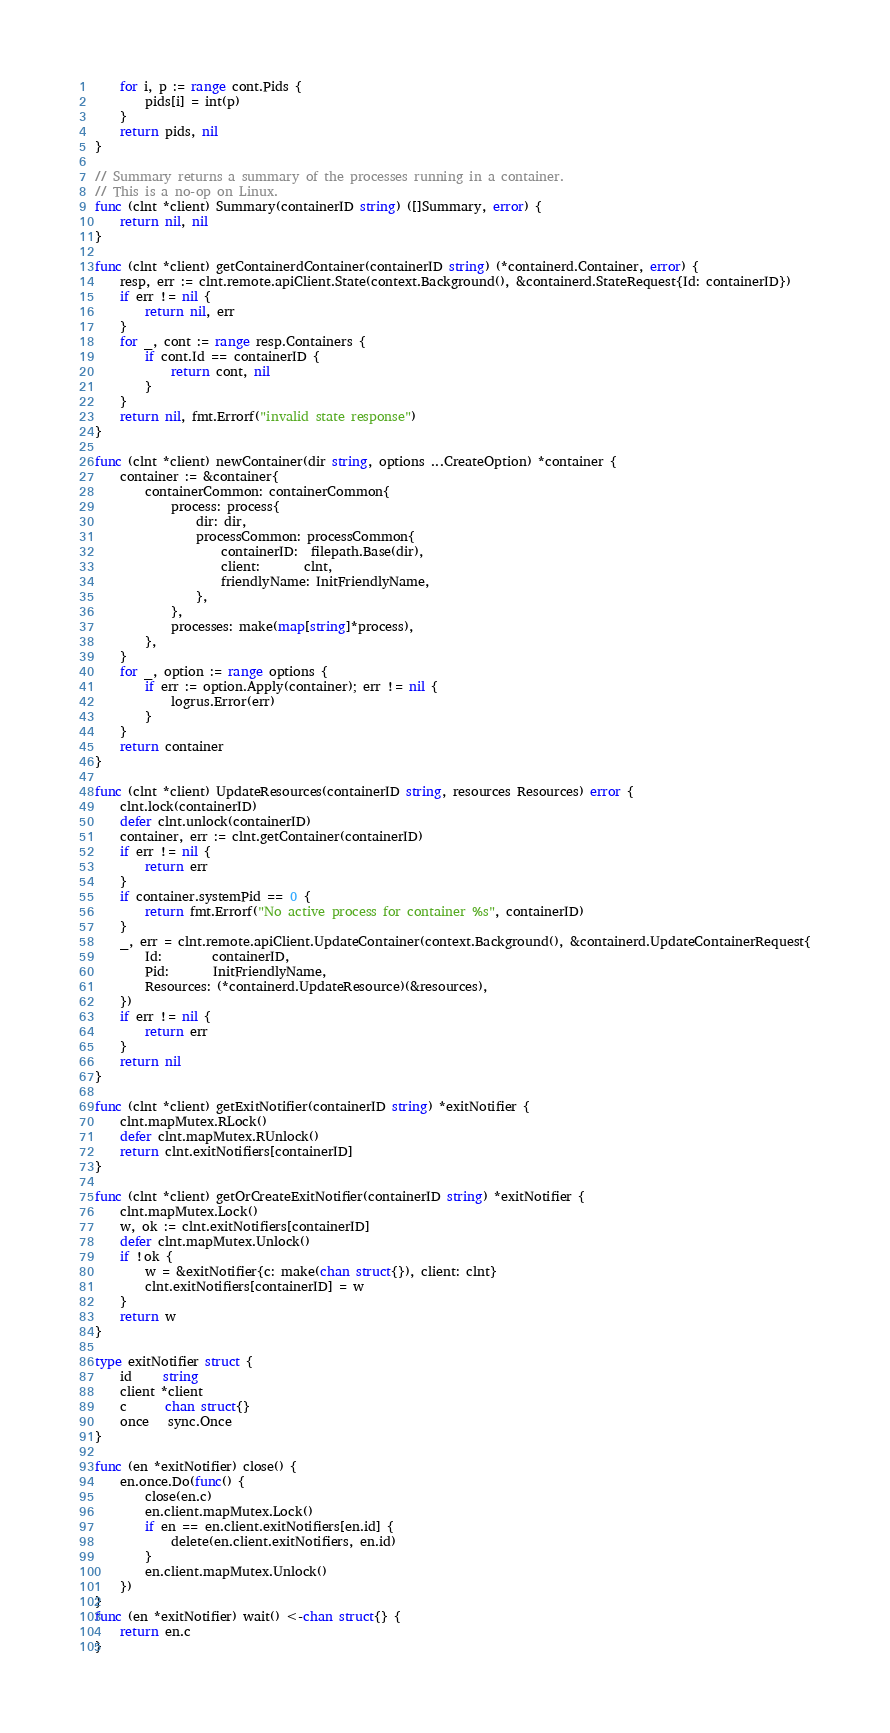<code> <loc_0><loc_0><loc_500><loc_500><_Go_>	for i, p := range cont.Pids {
		pids[i] = int(p)
	}
	return pids, nil
}

// Summary returns a summary of the processes running in a container.
// This is a no-op on Linux.
func (clnt *client) Summary(containerID string) ([]Summary, error) {
	return nil, nil
}

func (clnt *client) getContainerdContainer(containerID string) (*containerd.Container, error) {
	resp, err := clnt.remote.apiClient.State(context.Background(), &containerd.StateRequest{Id: containerID})
	if err != nil {
		return nil, err
	}
	for _, cont := range resp.Containers {
		if cont.Id == containerID {
			return cont, nil
		}
	}
	return nil, fmt.Errorf("invalid state response")
}

func (clnt *client) newContainer(dir string, options ...CreateOption) *container {
	container := &container{
		containerCommon: containerCommon{
			process: process{
				dir: dir,
				processCommon: processCommon{
					containerID:  filepath.Base(dir),
					client:       clnt,
					friendlyName: InitFriendlyName,
				},
			},
			processes: make(map[string]*process),
		},
	}
	for _, option := range options {
		if err := option.Apply(container); err != nil {
			logrus.Error(err)
		}
	}
	return container
}

func (clnt *client) UpdateResources(containerID string, resources Resources) error {
	clnt.lock(containerID)
	defer clnt.unlock(containerID)
	container, err := clnt.getContainer(containerID)
	if err != nil {
		return err
	}
	if container.systemPid == 0 {
		return fmt.Errorf("No active process for container %s", containerID)
	}
	_, err = clnt.remote.apiClient.UpdateContainer(context.Background(), &containerd.UpdateContainerRequest{
		Id:        containerID,
		Pid:       InitFriendlyName,
		Resources: (*containerd.UpdateResource)(&resources),
	})
	if err != nil {
		return err
	}
	return nil
}

func (clnt *client) getExitNotifier(containerID string) *exitNotifier {
	clnt.mapMutex.RLock()
	defer clnt.mapMutex.RUnlock()
	return clnt.exitNotifiers[containerID]
}

func (clnt *client) getOrCreateExitNotifier(containerID string) *exitNotifier {
	clnt.mapMutex.Lock()
	w, ok := clnt.exitNotifiers[containerID]
	defer clnt.mapMutex.Unlock()
	if !ok {
		w = &exitNotifier{c: make(chan struct{}), client: clnt}
		clnt.exitNotifiers[containerID] = w
	}
	return w
}

type exitNotifier struct {
	id     string
	client *client
	c      chan struct{}
	once   sync.Once
}

func (en *exitNotifier) close() {
	en.once.Do(func() {
		close(en.c)
		en.client.mapMutex.Lock()
		if en == en.client.exitNotifiers[en.id] {
			delete(en.client.exitNotifiers, en.id)
		}
		en.client.mapMutex.Unlock()
	})
}
func (en *exitNotifier) wait() <-chan struct{} {
	return en.c
}
</code> 